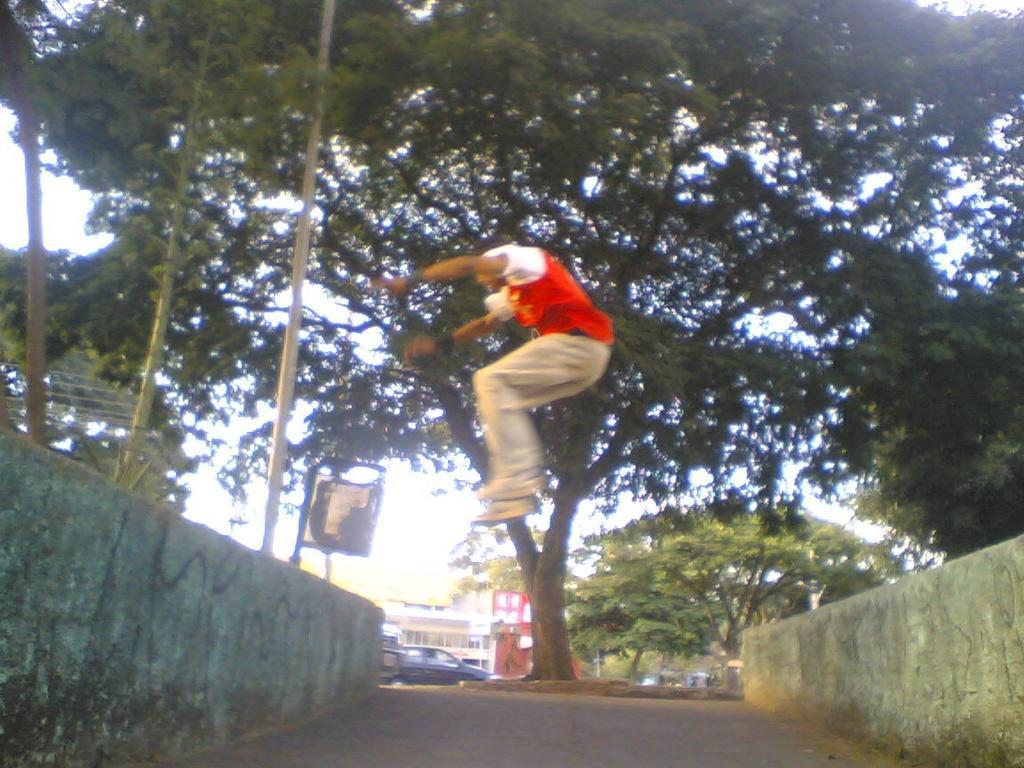Could you give a brief overview of what you see in this image? In this image, I can see a person jumping. These are the walls. This looks like a pathway. I can see the trees with branches and leaves. This looks like a car. In the background, I can see a building. These are the poles. 